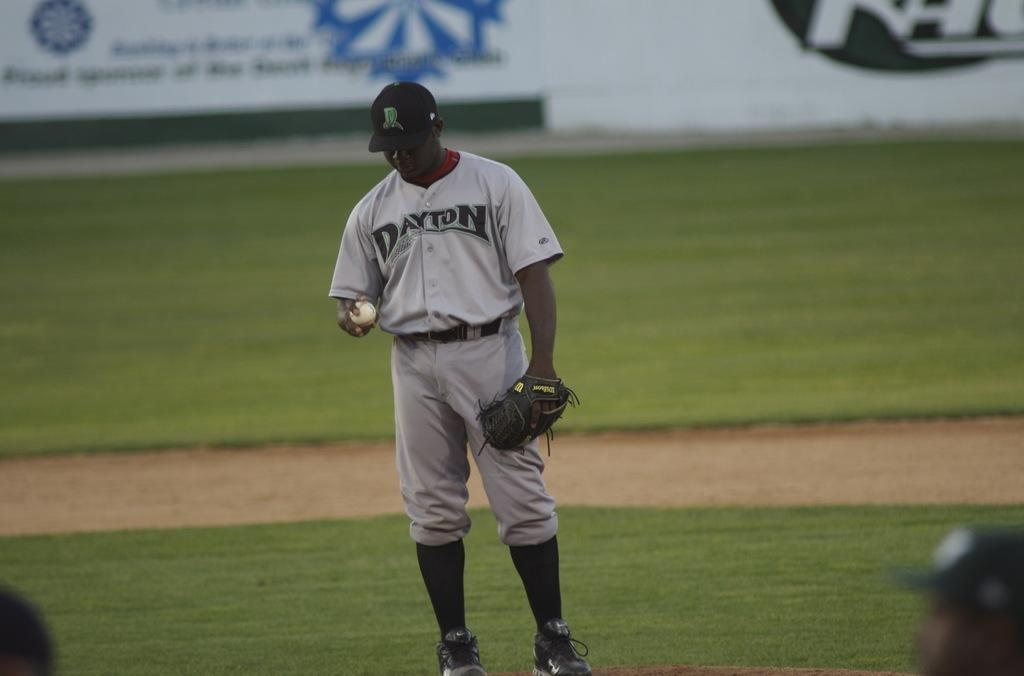<image>
Share a concise interpretation of the image provided. A player for Dayton stands on the field looking down at the ball in his hands 